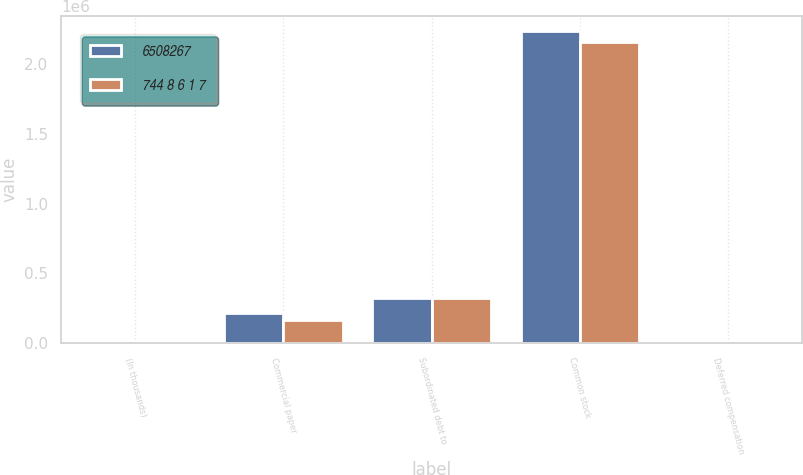Convert chart to OTSL. <chart><loc_0><loc_0><loc_500><loc_500><stacked_bar_chart><ecel><fcel>(In thousands)<fcel>Commercial paper<fcel>Subordinated debt to<fcel>Common stock<fcel>Deferred compensation<nl><fcel>6508267<fcel>2006<fcel>220507<fcel>324709<fcel>2.2303e+06<fcel>9620<nl><fcel>744 8 6 1 7<fcel>2005<fcel>167188<fcel>324709<fcel>2.15673e+06<fcel>16310<nl></chart> 